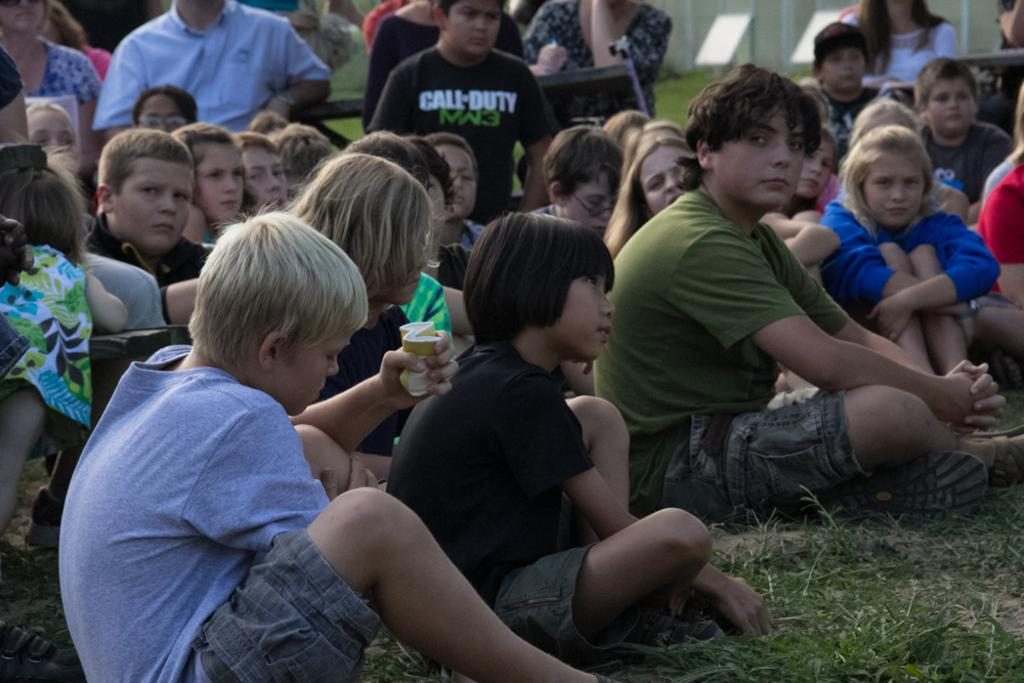What are the people in the image doing? There is a group of persons sitting in the image. What type of surface are they sitting on? There is grass on the ground in the image. What can be seen in the background of the image? There are boards and a wall in the background of the image. What is the income of the persons sitting in the image? There is no information about the income of the persons in the image. Can you describe the bedroom in the image? There is no bedroom present in the image. 